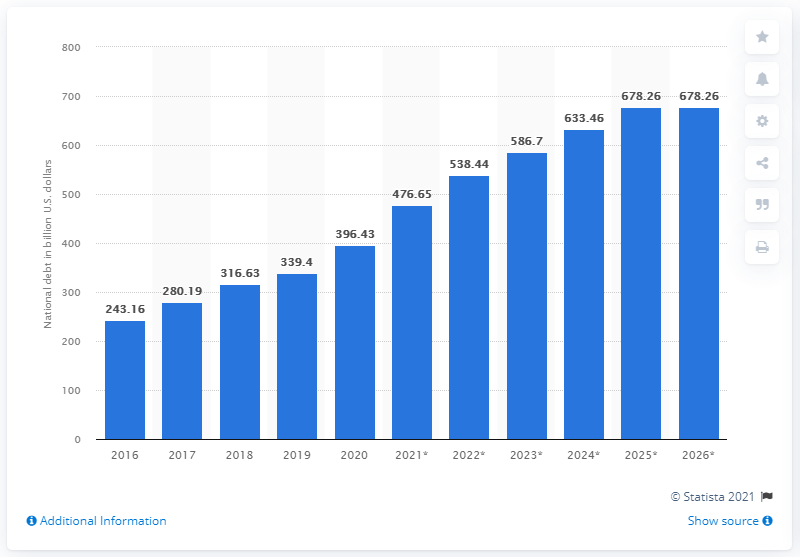Outline some significant characteristics in this image. The national debt of Indonesia came to an end in the year 2020. In 2020, the national debt of Indonesia was approximately 396.43 billion dollars. 